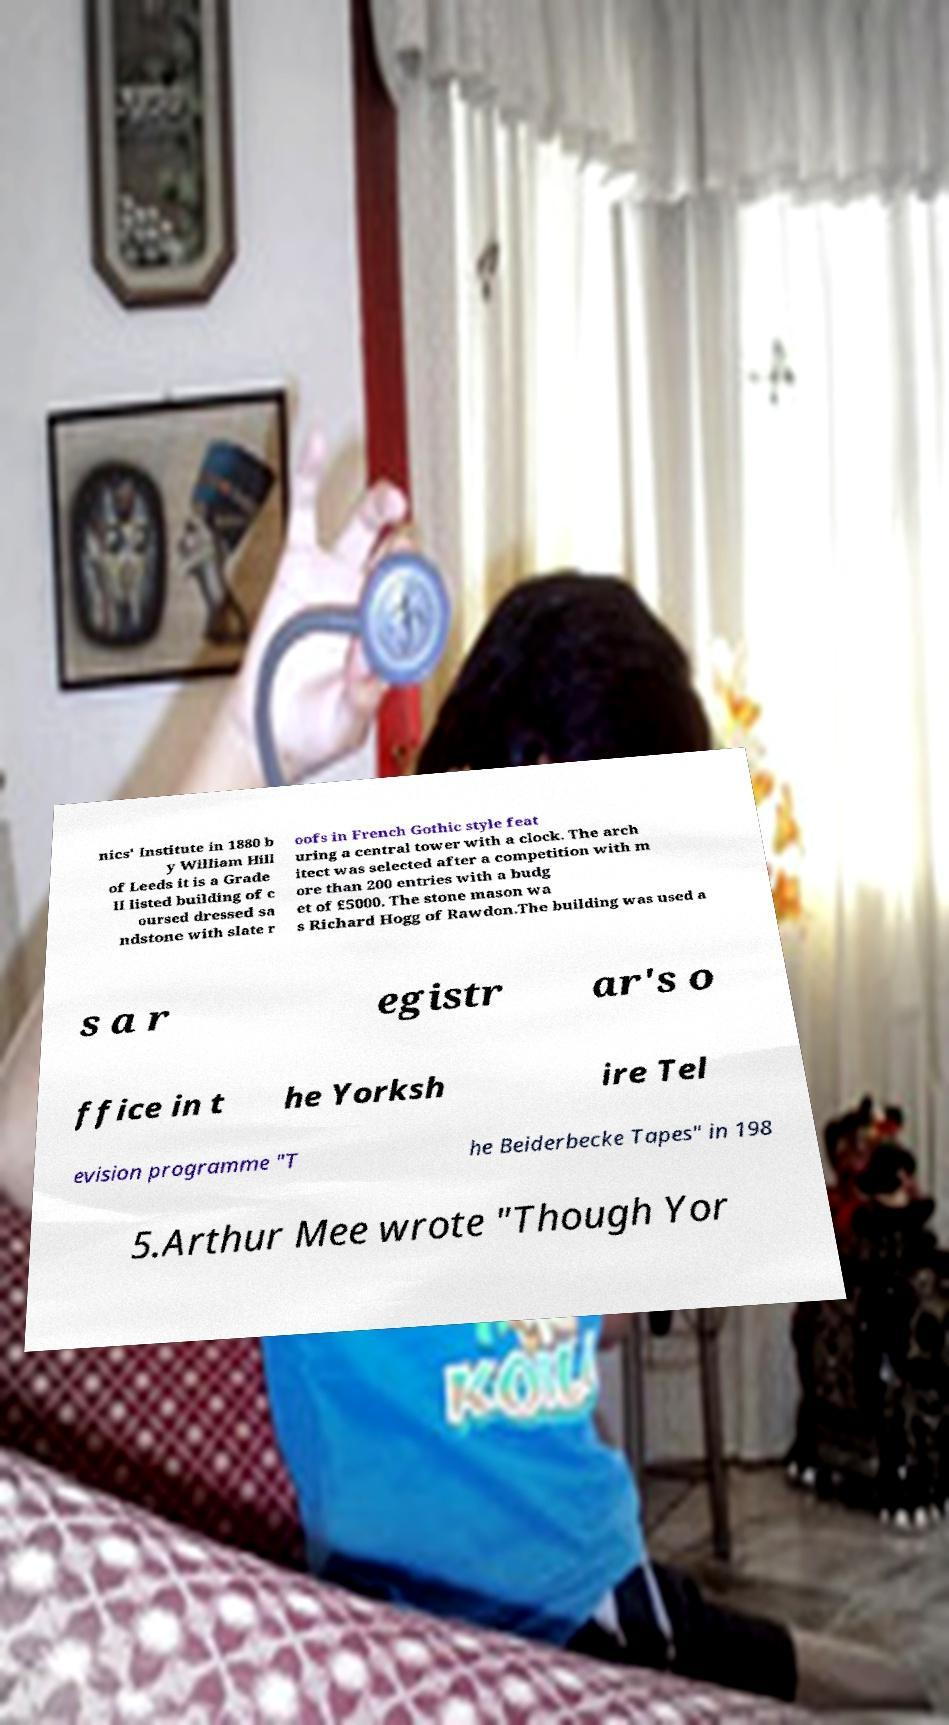Can you read and provide the text displayed in the image?This photo seems to have some interesting text. Can you extract and type it out for me? nics' Institute in 1880 b y William Hill of Leeds it is a Grade II listed building of c oursed dressed sa ndstone with slate r oofs in French Gothic style feat uring a central tower with a clock. The arch itect was selected after a competition with m ore than 200 entries with a budg et of £5000. The stone mason wa s Richard Hogg of Rawdon.The building was used a s a r egistr ar's o ffice in t he Yorksh ire Tel evision programme "T he Beiderbecke Tapes" in 198 5.Arthur Mee wrote "Though Yor 